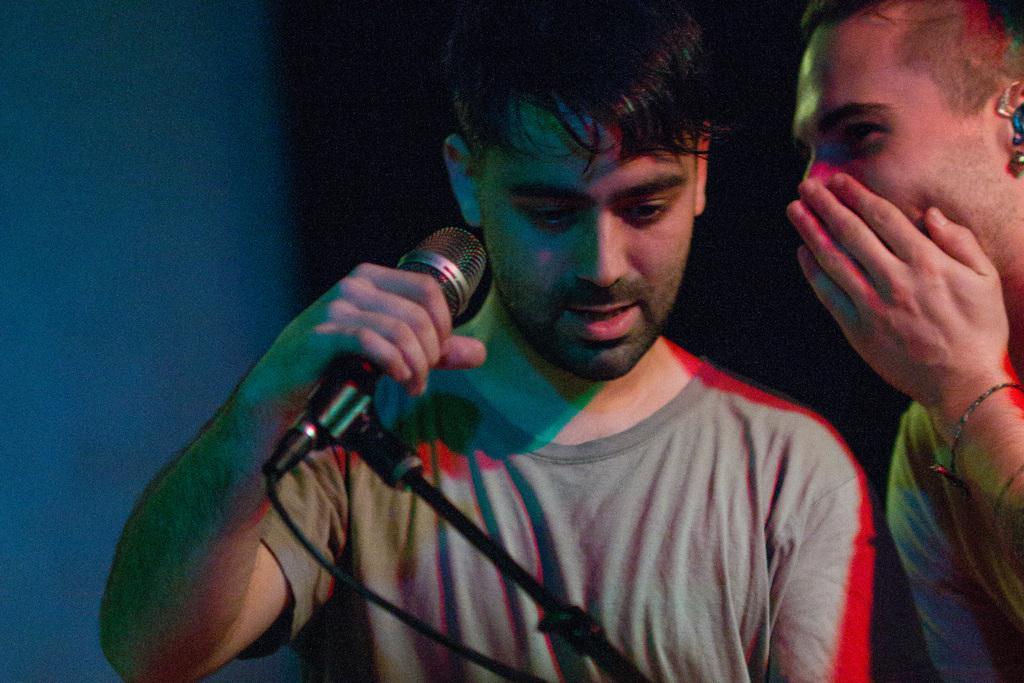Please provide a concise description of this image. In this image we can see this person is holding a mic with his hand and this person is covering his face with his hand. 